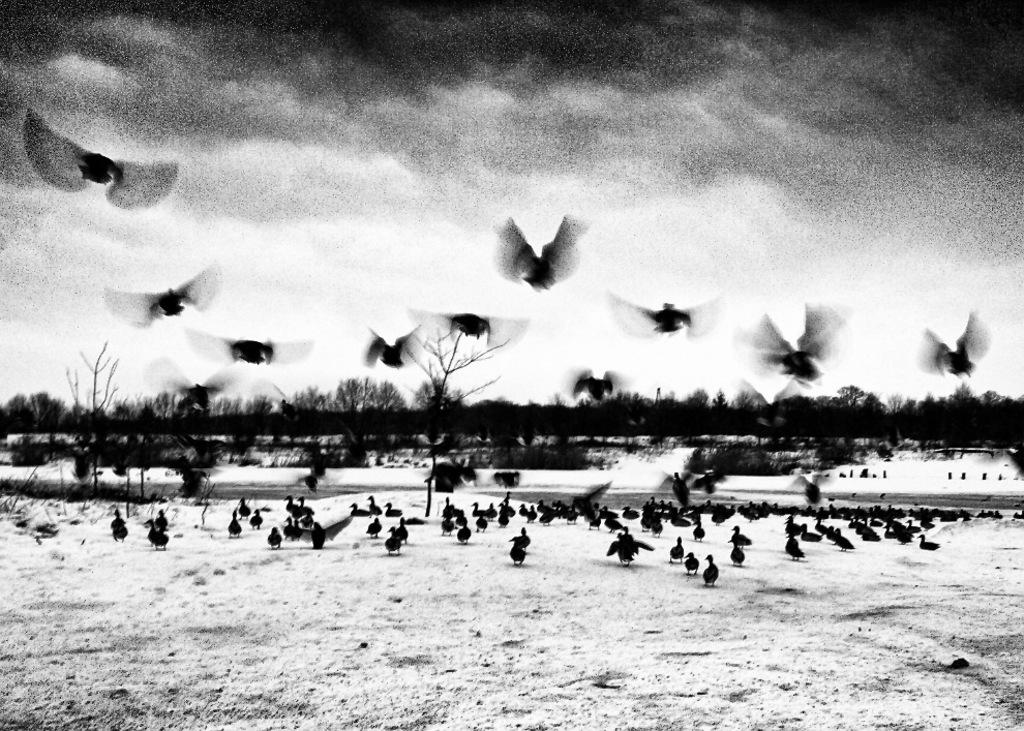What is located on the ground in the foreground of the image? There are birds on the ground in the foreground of the image. What are some birds doing in the foreground of the image? Some birds are flying in the air in the foreground of the image. What can be seen in the background of the image? There are trees and the sky visible in the background of the image. What is present in the sky in the background of the image? There are clouds in the sky in the background of the image. What type of quiver can be seen hanging from the tree in the image? There is no quiver present in the image; it features birds on the ground and in the air, trees, and clouds in the sky. 